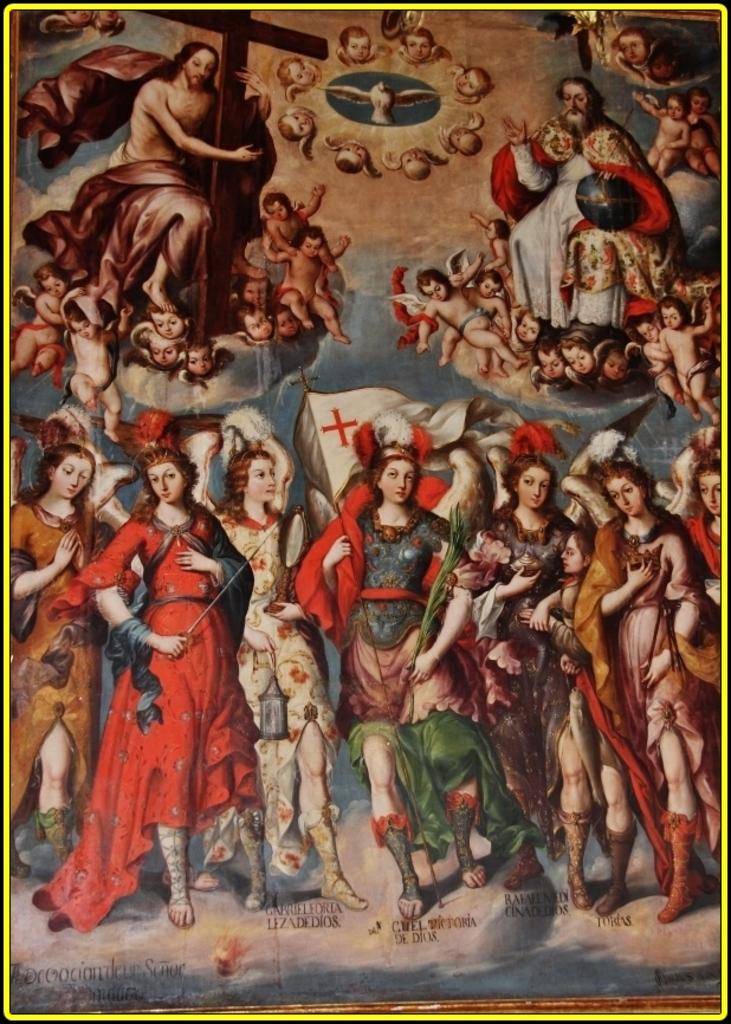What is the main object in the image? There is a poster in the image. What can be seen on the poster? The poster contains images of persons and a Christian cross. What type of soda is being advertised on the poster? There is no soda being advertised on the poster; it contains images of persons and a Christian cross. 